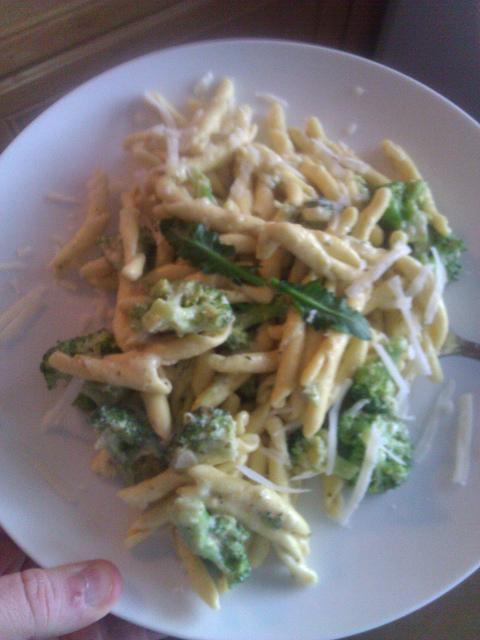Why is the leaf on top?
Pick the right solution, then justify: 'Answer: answer
Rationale: rationale.'
Options: Preservative, color, seasoning, garnish. Answer: garnish.
Rationale: The leaves help "seep down" so as to add flavor to the pasta, and then you can remove it when it has left its traces of flavor. 